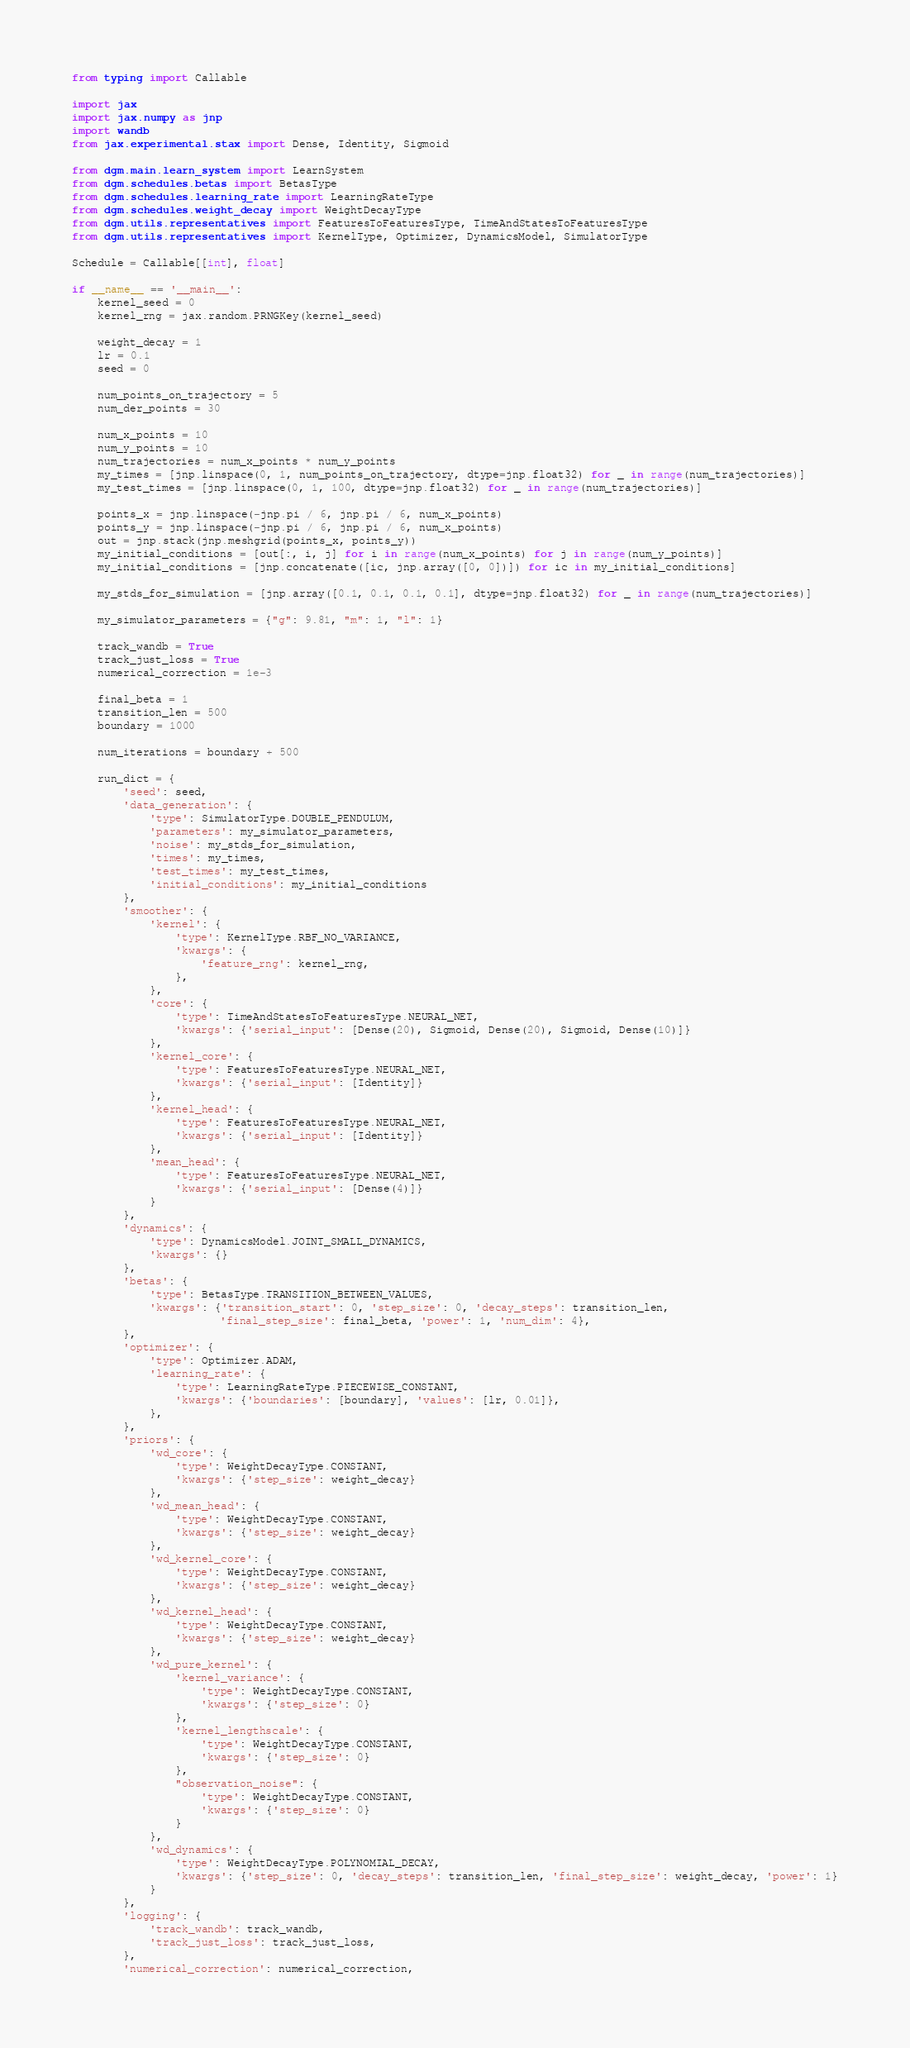Convert code to text. <code><loc_0><loc_0><loc_500><loc_500><_Python_>from typing import Callable

import jax
import jax.numpy as jnp
import wandb
from jax.experimental.stax import Dense, Identity, Sigmoid

from dgm.main.learn_system import LearnSystem
from dgm.schedules.betas import BetasType
from dgm.schedules.learning_rate import LearningRateType
from dgm.schedules.weight_decay import WeightDecayType
from dgm.utils.representatives import FeaturesToFeaturesType, TimeAndStatesToFeaturesType
from dgm.utils.representatives import KernelType, Optimizer, DynamicsModel, SimulatorType

Schedule = Callable[[int], float]

if __name__ == '__main__':
    kernel_seed = 0
    kernel_rng = jax.random.PRNGKey(kernel_seed)

    weight_decay = 1
    lr = 0.1
    seed = 0

    num_points_on_trajectory = 5
    num_der_points = 30

    num_x_points = 10
    num_y_points = 10
    num_trajectories = num_x_points * num_y_points
    my_times = [jnp.linspace(0, 1, num_points_on_trajectory, dtype=jnp.float32) for _ in range(num_trajectories)]
    my_test_times = [jnp.linspace(0, 1, 100, dtype=jnp.float32) for _ in range(num_trajectories)]

    points_x = jnp.linspace(-jnp.pi / 6, jnp.pi / 6, num_x_points)
    points_y = jnp.linspace(-jnp.pi / 6, jnp.pi / 6, num_x_points)
    out = jnp.stack(jnp.meshgrid(points_x, points_y))
    my_initial_conditions = [out[:, i, j] for i in range(num_x_points) for j in range(num_y_points)]
    my_initial_conditions = [jnp.concatenate([ic, jnp.array([0, 0])]) for ic in my_initial_conditions]

    my_stds_for_simulation = [jnp.array([0.1, 0.1, 0.1, 0.1], dtype=jnp.float32) for _ in range(num_trajectories)]

    my_simulator_parameters = {"g": 9.81, "m": 1, "l": 1}

    track_wandb = True
    track_just_loss = True
    numerical_correction = 1e-3

    final_beta = 1
    transition_len = 500
    boundary = 1000

    num_iterations = boundary + 500

    run_dict = {
        'seed': seed,
        'data_generation': {
            'type': SimulatorType.DOUBLE_PENDULUM,
            'parameters': my_simulator_parameters,
            'noise': my_stds_for_simulation,
            'times': my_times,
            'test_times': my_test_times,
            'initial_conditions': my_initial_conditions
        },
        'smoother': {
            'kernel': {
                'type': KernelType.RBF_NO_VARIANCE,
                'kwargs': {
                    'feature_rng': kernel_rng,
                },
            },
            'core': {
                'type': TimeAndStatesToFeaturesType.NEURAL_NET,
                'kwargs': {'serial_input': [Dense(20), Sigmoid, Dense(20), Sigmoid, Dense(10)]}
            },
            'kernel_core': {
                'type': FeaturesToFeaturesType.NEURAL_NET,
                'kwargs': {'serial_input': [Identity]}
            },
            'kernel_head': {
                'type': FeaturesToFeaturesType.NEURAL_NET,
                'kwargs': {'serial_input': [Identity]}
            },
            'mean_head': {
                'type': FeaturesToFeaturesType.NEURAL_NET,
                'kwargs': {'serial_input': [Dense(4)]}
            }
        },
        'dynamics': {
            'type': DynamicsModel.JOINT_SMALL_DYNAMICS,
            'kwargs': {}
        },
        'betas': {
            'type': BetasType.TRANSITION_BETWEEN_VALUES,
            'kwargs': {'transition_start': 0, 'step_size': 0, 'decay_steps': transition_len,
                       'final_step_size': final_beta, 'power': 1, 'num_dim': 4},
        },
        'optimizer': {
            'type': Optimizer.ADAM,
            'learning_rate': {
                'type': LearningRateType.PIECEWISE_CONSTANT,
                'kwargs': {'boundaries': [boundary], 'values': [lr, 0.01]},
            },
        },
        'priors': {
            'wd_core': {
                'type': WeightDecayType.CONSTANT,
                'kwargs': {'step_size': weight_decay}
            },
            'wd_mean_head': {
                'type': WeightDecayType.CONSTANT,
                'kwargs': {'step_size': weight_decay}
            },
            'wd_kernel_core': {
                'type': WeightDecayType.CONSTANT,
                'kwargs': {'step_size': weight_decay}
            },
            'wd_kernel_head': {
                'type': WeightDecayType.CONSTANT,
                'kwargs': {'step_size': weight_decay}
            },
            'wd_pure_kernel': {
                'kernel_variance': {
                    'type': WeightDecayType.CONSTANT,
                    'kwargs': {'step_size': 0}
                },
                'kernel_lengthscale': {
                    'type': WeightDecayType.CONSTANT,
                    'kwargs': {'step_size': 0}
                },
                "observation_noise": {
                    'type': WeightDecayType.CONSTANT,
                    'kwargs': {'step_size': 0}
                }
            },
            'wd_dynamics': {
                'type': WeightDecayType.POLYNOMIAL_DECAY,
                'kwargs': {'step_size': 0, 'decay_steps': transition_len, 'final_step_size': weight_decay, 'power': 1}
            }
        },
        'logging': {
            'track_wandb': track_wandb,
            'track_just_loss': track_just_loss,
        },
        'numerical_correction': numerical_correction,</code> 